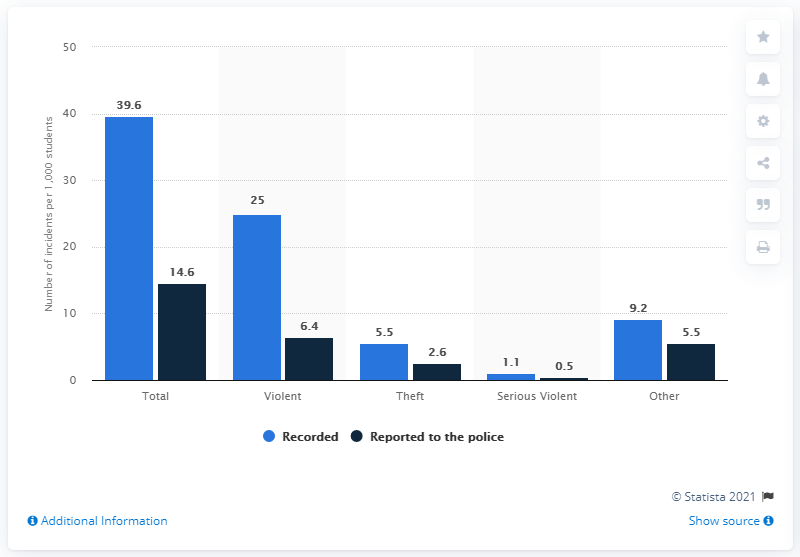Identify some key points in this picture. In the school year 2009-10, it was reported that 5.5% of students at public schools were victims of theft. 